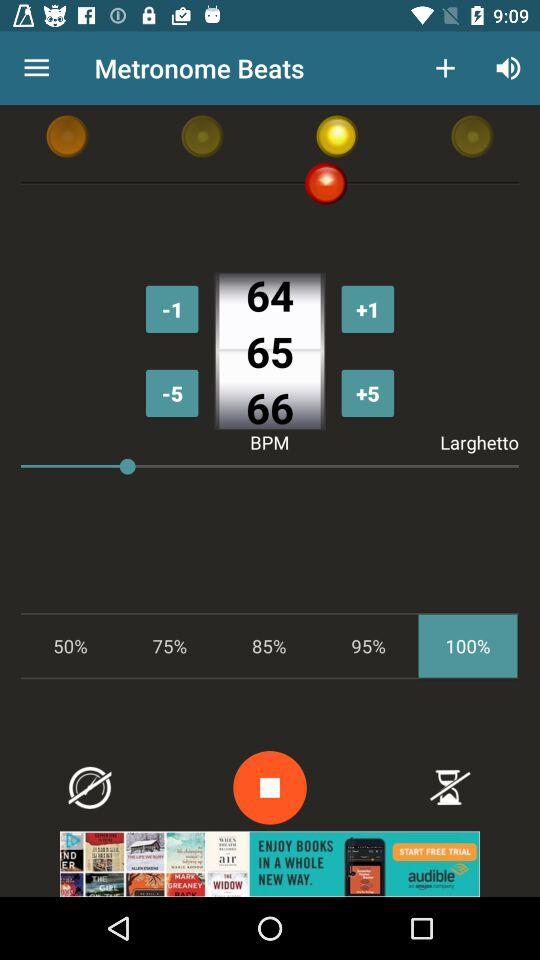What is the selected percentage? The selected percentage is 100. 